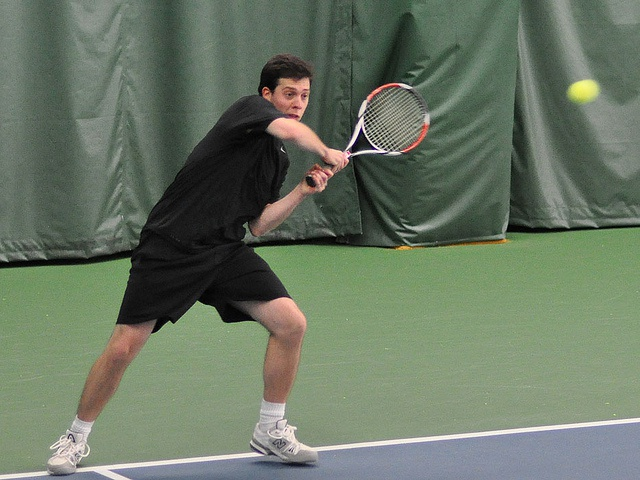Describe the objects in this image and their specific colors. I can see people in gray, black, and darkgray tones, tennis racket in gray, darkgray, black, and ivory tones, and sports ball in gray, khaki, olive, and darkgray tones in this image. 